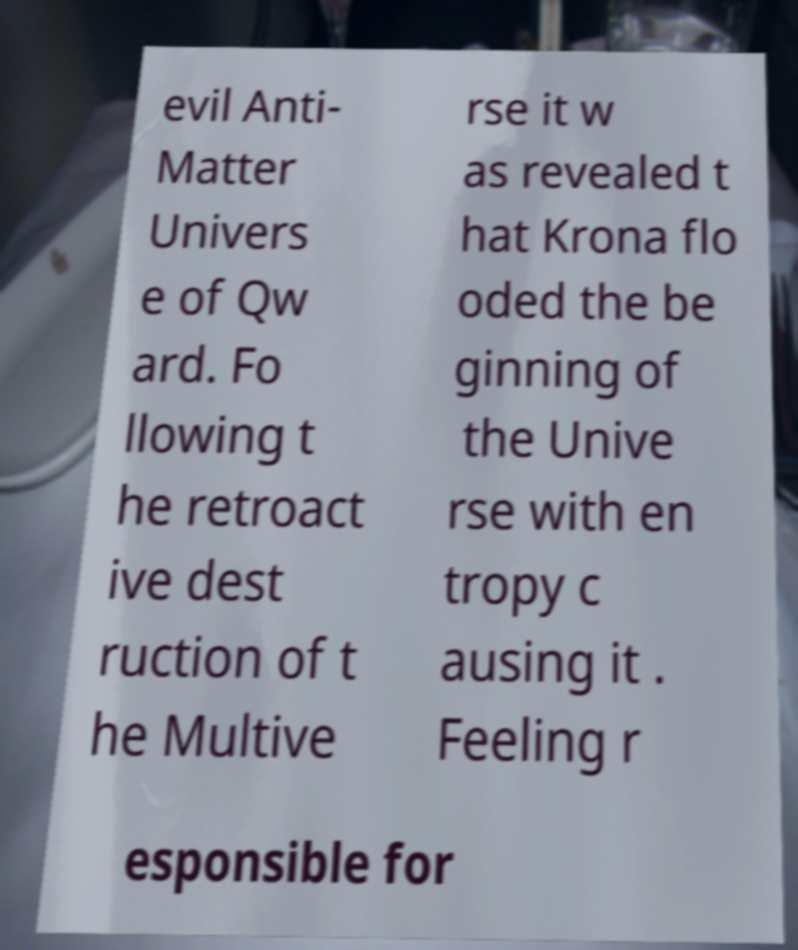Could you extract and type out the text from this image? evil Anti- Matter Univers e of Qw ard. Fo llowing t he retroact ive dest ruction of t he Multive rse it w as revealed t hat Krona flo oded the be ginning of the Unive rse with en tropy c ausing it . Feeling r esponsible for 